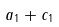Convert formula to latex. <formula><loc_0><loc_0><loc_500><loc_500>a _ { 1 } + c _ { 1 }</formula> 